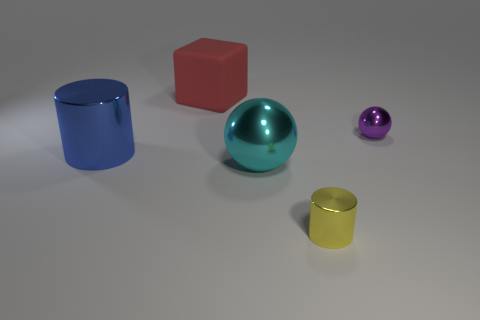Add 1 red matte cubes. How many objects exist? 6 Subtract 1 yellow cylinders. How many objects are left? 4 Subtract all cylinders. How many objects are left? 3 Subtract all large cyan matte spheres. Subtract all large blue things. How many objects are left? 4 Add 3 yellow shiny cylinders. How many yellow shiny cylinders are left? 4 Add 3 large green matte objects. How many large green matte objects exist? 3 